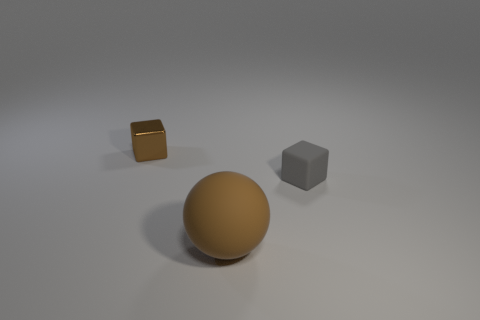Is the number of metal things that are on the right side of the sphere less than the number of large matte spheres that are to the right of the metallic block?
Keep it short and to the point. Yes. There is another tiny object that is the same shape as the small brown metallic thing; what is it made of?
Keep it short and to the point. Rubber. Are there any other things that are the same material as the tiny brown object?
Ensure brevity in your answer.  No. Is the large sphere the same color as the shiny cube?
Your answer should be compact. Yes. The brown object that is the same material as the small gray block is what shape?
Make the answer very short. Sphere. How many tiny things have the same shape as the big rubber object?
Your answer should be compact. 0. What shape is the matte object that is on the left side of the small thing that is in front of the metallic object?
Your answer should be very brief. Sphere. Does the thing behind the gray block have the same size as the gray matte thing?
Your answer should be very brief. Yes. What is the size of the thing that is in front of the brown shiny object and on the left side of the rubber cube?
Ensure brevity in your answer.  Large. What number of brown objects are the same size as the brown sphere?
Your response must be concise. 0. 